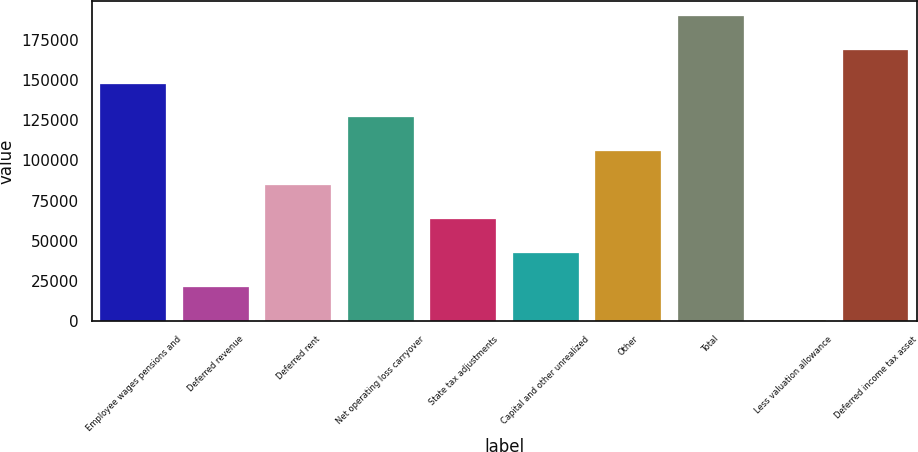Convert chart. <chart><loc_0><loc_0><loc_500><loc_500><bar_chart><fcel>Employee wages pensions and<fcel>Deferred revenue<fcel>Deferred rent<fcel>Net operating loss carryover<fcel>State tax adjustments<fcel>Capital and other unrealized<fcel>Other<fcel>Total<fcel>Less valuation allowance<fcel>Deferred income tax asset<nl><fcel>147727<fcel>21613.9<fcel>84670.6<fcel>126708<fcel>63651.7<fcel>42632.8<fcel>105690<fcel>189765<fcel>595<fcel>168746<nl></chart> 